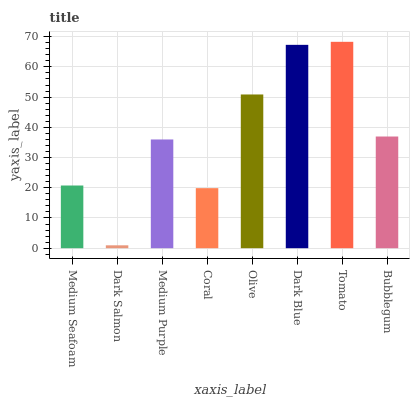Is Dark Salmon the minimum?
Answer yes or no. Yes. Is Tomato the maximum?
Answer yes or no. Yes. Is Medium Purple the minimum?
Answer yes or no. No. Is Medium Purple the maximum?
Answer yes or no. No. Is Medium Purple greater than Dark Salmon?
Answer yes or no. Yes. Is Dark Salmon less than Medium Purple?
Answer yes or no. Yes. Is Dark Salmon greater than Medium Purple?
Answer yes or no. No. Is Medium Purple less than Dark Salmon?
Answer yes or no. No. Is Bubblegum the high median?
Answer yes or no. Yes. Is Medium Purple the low median?
Answer yes or no. Yes. Is Medium Purple the high median?
Answer yes or no. No. Is Dark Salmon the low median?
Answer yes or no. No. 